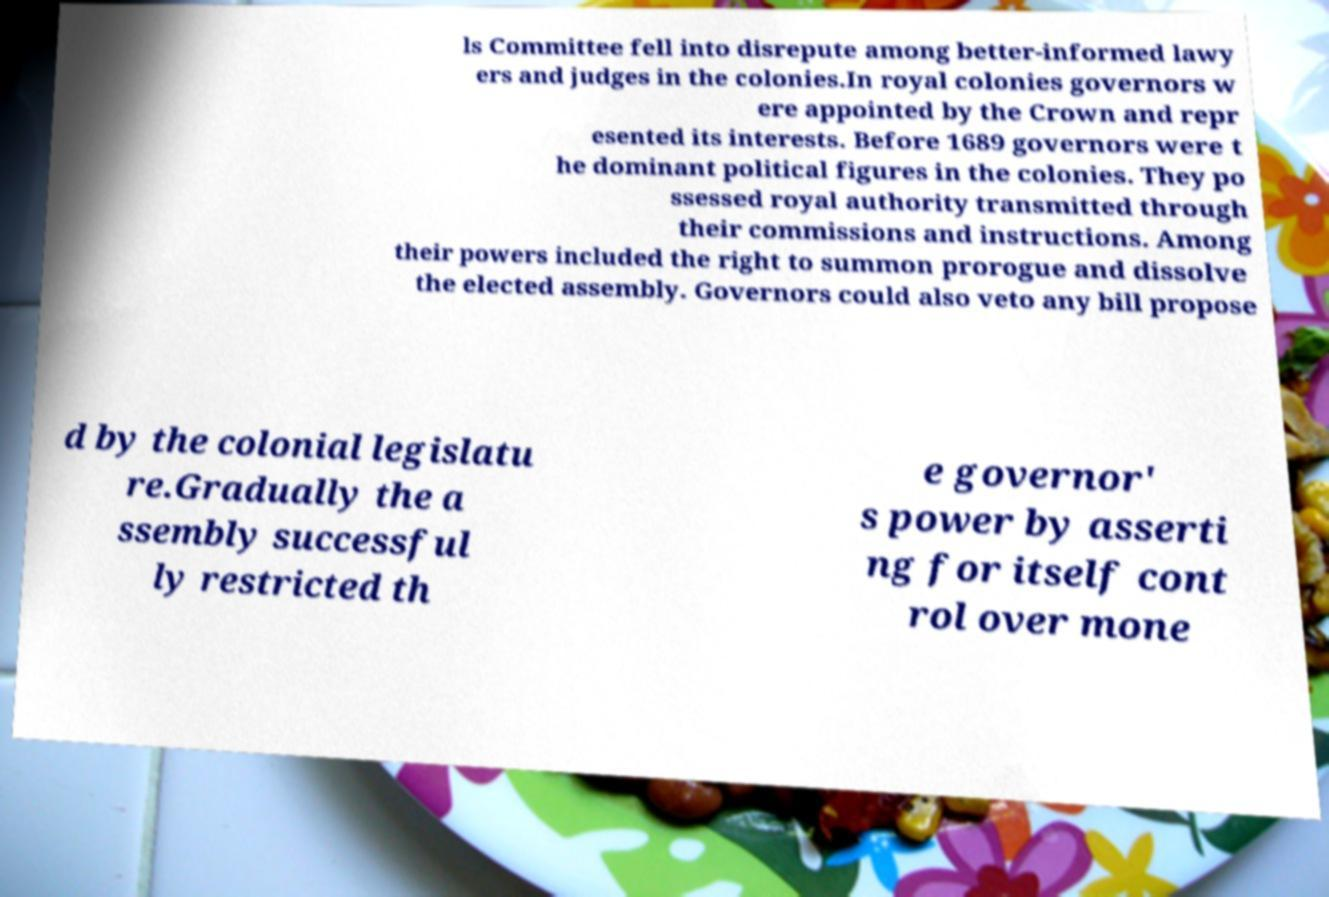There's text embedded in this image that I need extracted. Can you transcribe it verbatim? ls Committee fell into disrepute among better-informed lawy ers and judges in the colonies.In royal colonies governors w ere appointed by the Crown and repr esented its interests. Before 1689 governors were t he dominant political figures in the colonies. They po ssessed royal authority transmitted through their commissions and instructions. Among their powers included the right to summon prorogue and dissolve the elected assembly. Governors could also veto any bill propose d by the colonial legislatu re.Gradually the a ssembly successful ly restricted th e governor' s power by asserti ng for itself cont rol over mone 